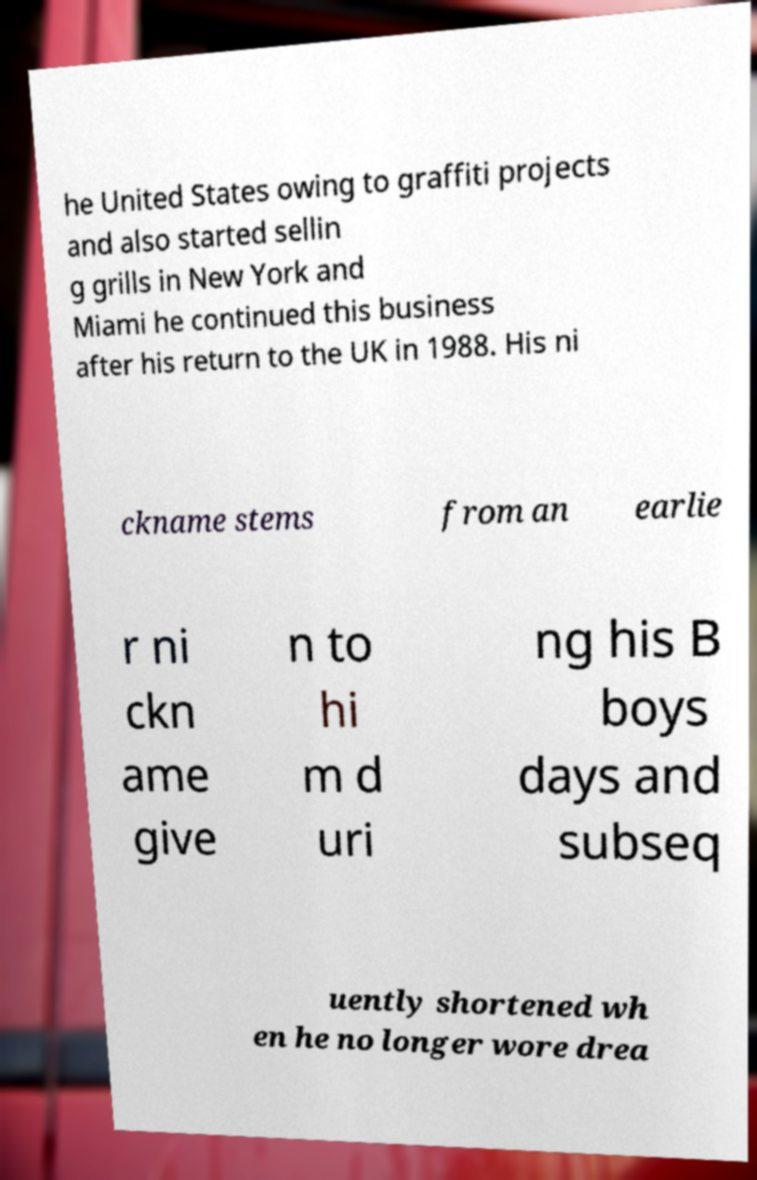There's text embedded in this image that I need extracted. Can you transcribe it verbatim? he United States owing to graffiti projects and also started sellin g grills in New York and Miami he continued this business after his return to the UK in 1988. His ni ckname stems from an earlie r ni ckn ame give n to hi m d uri ng his B boys days and subseq uently shortened wh en he no longer wore drea 